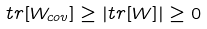<formula> <loc_0><loc_0><loc_500><loc_500>t r [ W _ { c o v } ] \geq \left | t r [ W ] \right | \geq 0</formula> 